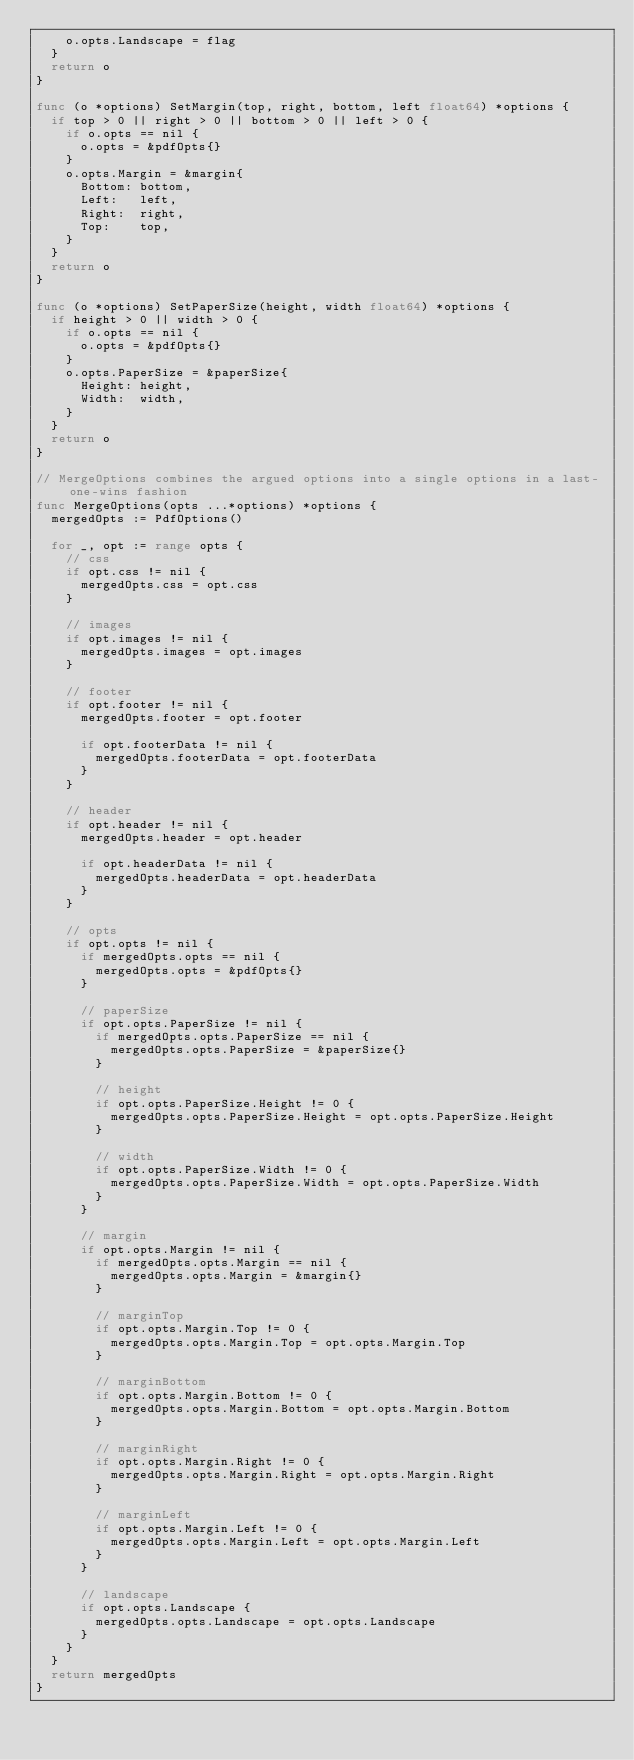Convert code to text. <code><loc_0><loc_0><loc_500><loc_500><_Go_>		o.opts.Landscape = flag
	}
	return o
}

func (o *options) SetMargin(top, right, bottom, left float64) *options {
	if top > 0 || right > 0 || bottom > 0 || left > 0 {
		if o.opts == nil {
			o.opts = &pdfOpts{}
		}
		o.opts.Margin = &margin{
			Bottom: bottom,
			Left:   left,
			Right:  right,
			Top:    top,
		}
	}
	return o
}

func (o *options) SetPaperSize(height, width float64) *options {
	if height > 0 || width > 0 {
		if o.opts == nil {
			o.opts = &pdfOpts{}
		}
		o.opts.PaperSize = &paperSize{
			Height: height,
			Width:  width,
		}
	}
	return o
}

// MergeOptions combines the argued options into a single options in a last-one-wins fashion
func MergeOptions(opts ...*options) *options {
	mergedOpts := PdfOptions()

	for _, opt := range opts {
		// css
		if opt.css != nil {
			mergedOpts.css = opt.css
		}

		// images
		if opt.images != nil {
			mergedOpts.images = opt.images
		}

		// footer
		if opt.footer != nil {
			mergedOpts.footer = opt.footer

			if opt.footerData != nil {
				mergedOpts.footerData = opt.footerData
			}
		}

		// header
		if opt.header != nil {
			mergedOpts.header = opt.header

			if opt.headerData != nil {
				mergedOpts.headerData = opt.headerData
			}
		}

		// opts
		if opt.opts != nil {
			if mergedOpts.opts == nil {
				mergedOpts.opts = &pdfOpts{}
			}

			// paperSize
			if opt.opts.PaperSize != nil {
				if mergedOpts.opts.PaperSize == nil {
					mergedOpts.opts.PaperSize = &paperSize{}
				}

				// height
				if opt.opts.PaperSize.Height != 0 {
					mergedOpts.opts.PaperSize.Height = opt.opts.PaperSize.Height
				}

				// width
				if opt.opts.PaperSize.Width != 0 {
					mergedOpts.opts.PaperSize.Width = opt.opts.PaperSize.Width
				}
			}

			// margin
			if opt.opts.Margin != nil {
				if mergedOpts.opts.Margin == nil {
					mergedOpts.opts.Margin = &margin{}
				}

				// marginTop
				if opt.opts.Margin.Top != 0 {
					mergedOpts.opts.Margin.Top = opt.opts.Margin.Top
				}

				// marginBottom
				if opt.opts.Margin.Bottom != 0 {
					mergedOpts.opts.Margin.Bottom = opt.opts.Margin.Bottom
				}

				// marginRight
				if opt.opts.Margin.Right != 0 {
					mergedOpts.opts.Margin.Right = opt.opts.Margin.Right
				}

				// marginLeft
				if opt.opts.Margin.Left != 0 {
					mergedOpts.opts.Margin.Left = opt.opts.Margin.Left
				}
			}

			// landscape
			if opt.opts.Landscape {
				mergedOpts.opts.Landscape = opt.opts.Landscape
			}
		}
	}
	return mergedOpts
}
</code> 